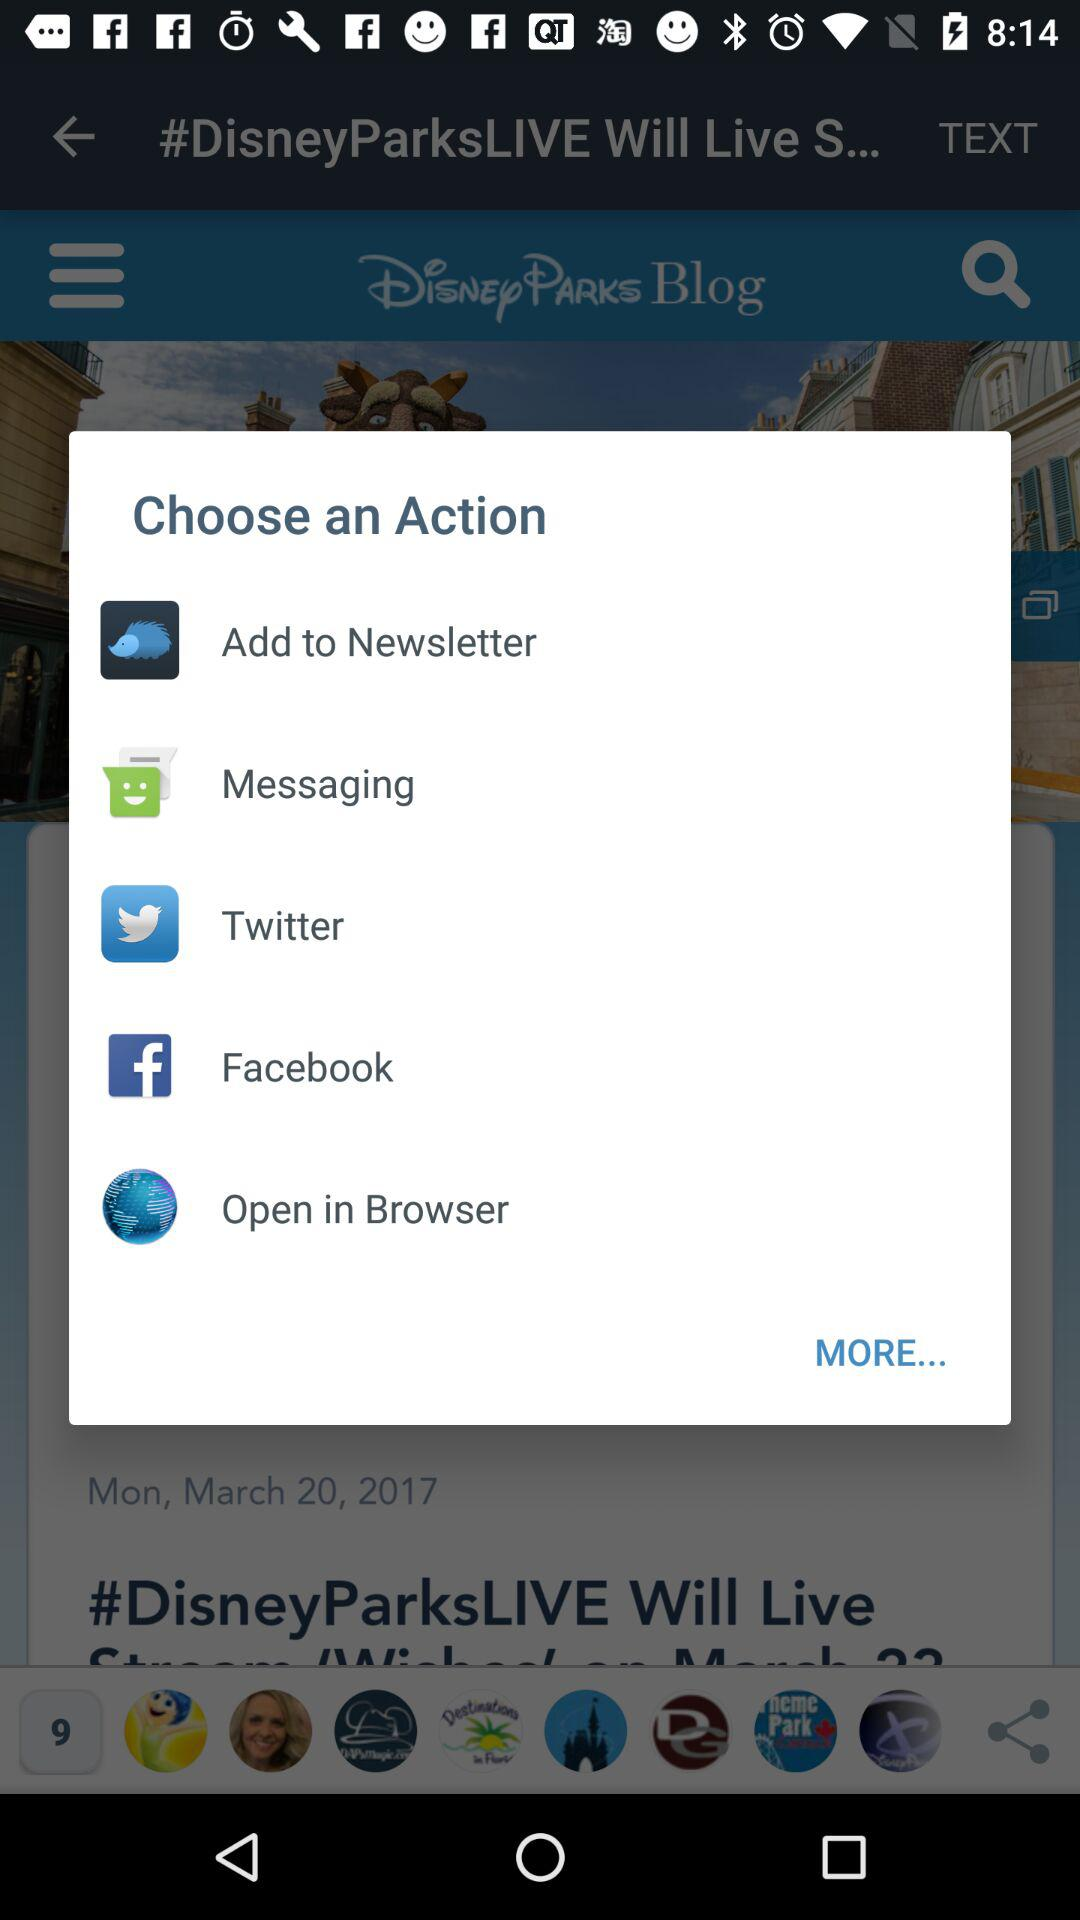Which apps can be chosen as an action? The apps that can be chosen as an action are "Add to Newsletter", "Messaging", "Twitter", "Facebook" and "Browser". 